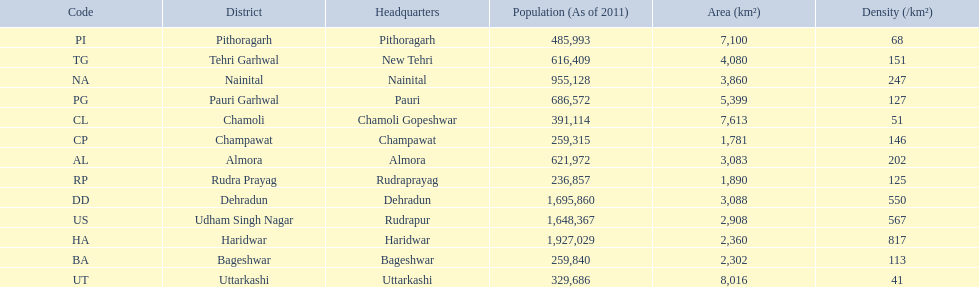What are all the districts? Almora, Bageshwar, Chamoli, Champawat, Dehradun, Haridwar, Nainital, Pauri Garhwal, Pithoragarh, Rudra Prayag, Tehri Garhwal, Udham Singh Nagar, Uttarkashi. And their densities? 202, 113, 51, 146, 550, 817, 247, 127, 68, 125, 151, 567, 41. Now, which district's density is 51? Chamoli. 